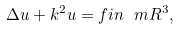<formula> <loc_0><loc_0><loc_500><loc_500>\Delta u + k ^ { 2 } u = f i n \ m R ^ { 3 } ,</formula> 